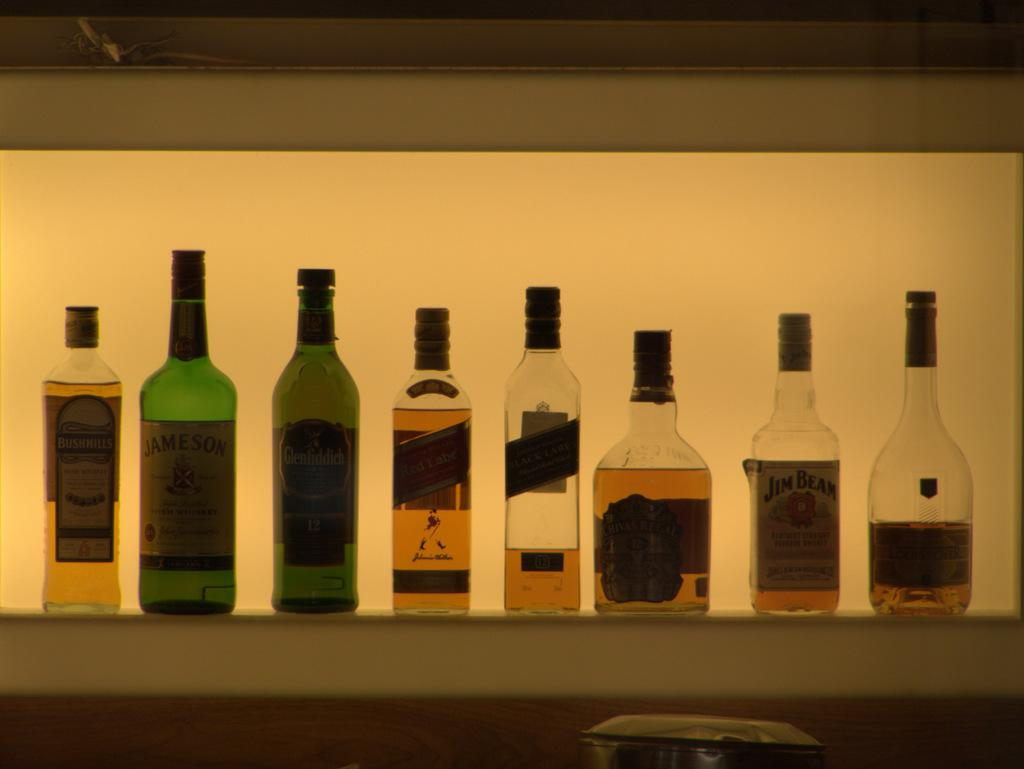What can be seen in the image? There are different types of bottles in the image. Can you describe the bottles in more detail? Unfortunately, the facts provided do not give any specific details about the bottles. How many bottles are there in the image? The number of bottles in the image is not mentioned in the provided facts. How many babies are sitting on the comb in the image? There are no babies or combs present in the image; it only features different types of bottles. 